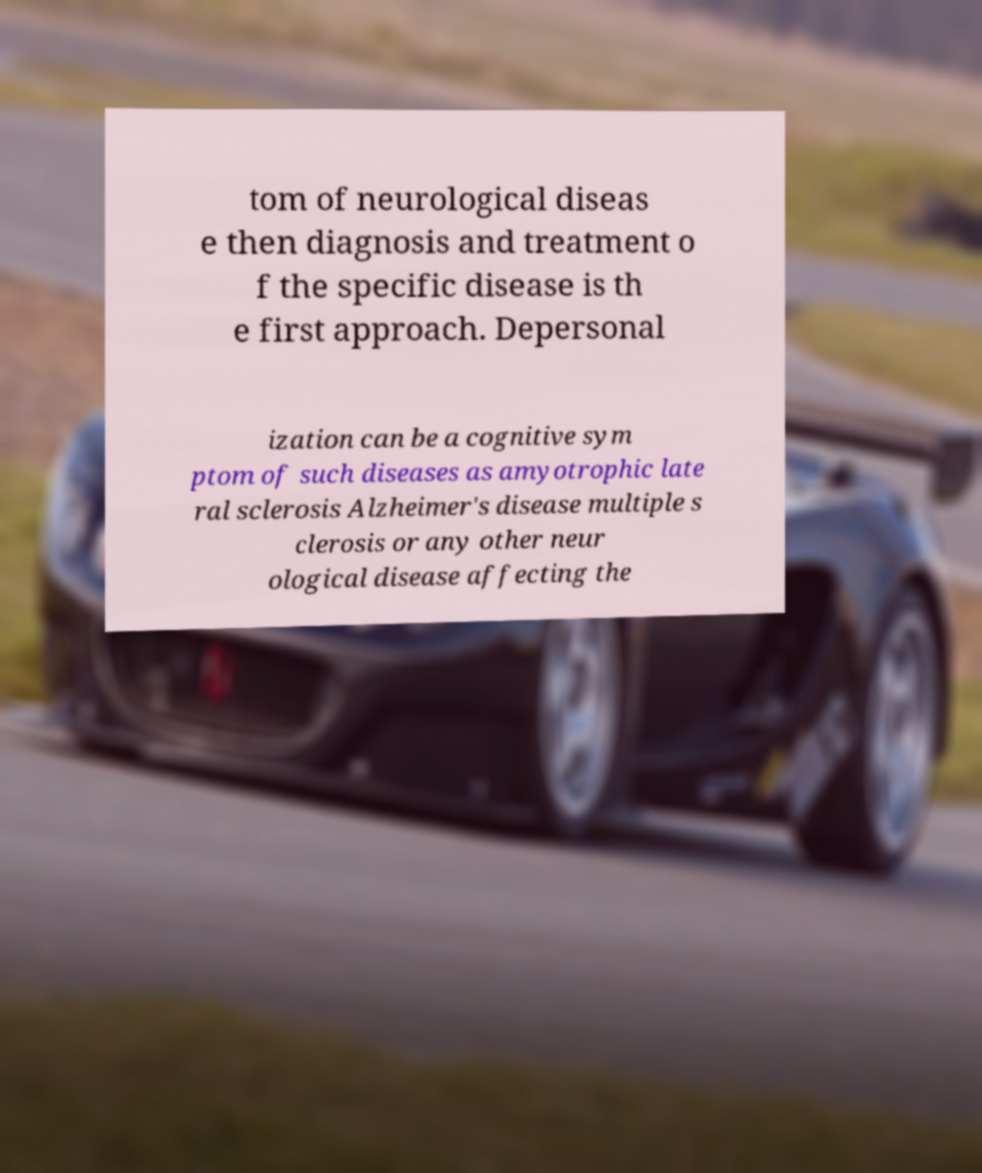I need the written content from this picture converted into text. Can you do that? tom of neurological diseas e then diagnosis and treatment o f the specific disease is th e first approach. Depersonal ization can be a cognitive sym ptom of such diseases as amyotrophic late ral sclerosis Alzheimer's disease multiple s clerosis or any other neur ological disease affecting the 